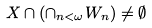<formula> <loc_0><loc_0><loc_500><loc_500>X \cap ( \cap _ { n < \omega } W _ { n } ) \ne \emptyset</formula> 